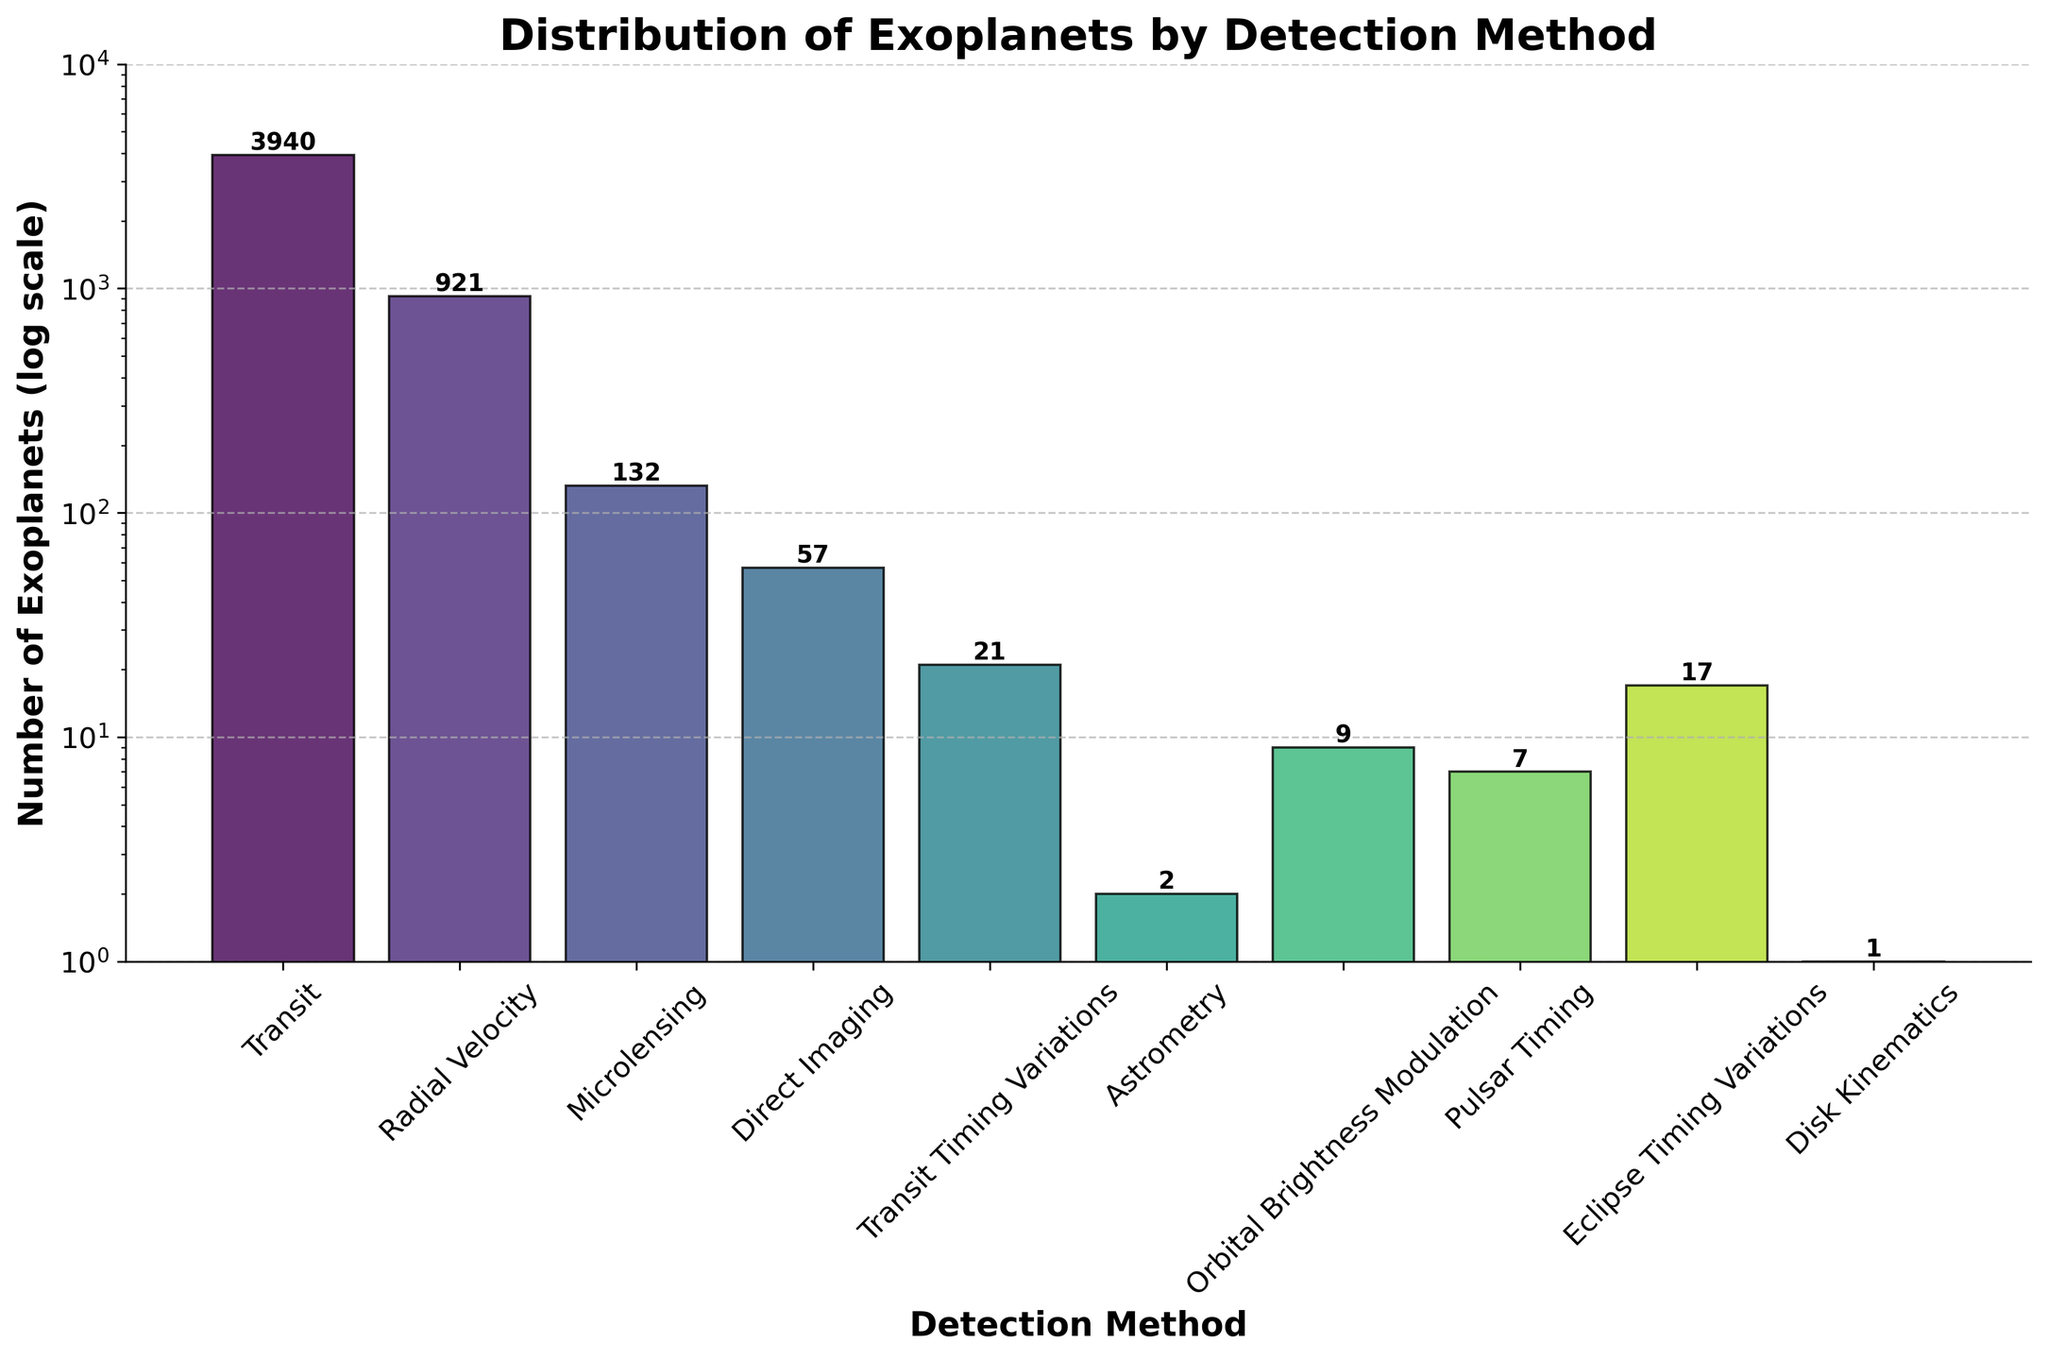Which detection method has discovered the most exoplanets? The bar representing the "Transit" method is the tallest in the chart. This indicates that the Transit method has discovered the highest number of exoplanets.
Answer: Transit What is the detection method with the second-highest number of discovered exoplanets? The second tallest bar in the chart corresponds to the "Radial Velocity" method. This bar is shorter than the "Transit" method but taller than the rest.
Answer: Radial Velocity How many exoplanets have been discovered using the Direct Imaging method? The height of the bar for "Direct Imaging" has the value written directly above it, indicating the number of discovered exoplanets.
Answer: 57 What is the sum of exoplanets discovered through Microlensing and Direct Imaging methods? The number of exoplanets discovered by Microlensing is 132, and by Direct Imaging is 57. Adding these values gives 132 + 57 = 189.
Answer: 189 Which detection methods have discovered fewer than 10 exoplanets? The bars for "Astrometry", "Orbital Brightness Modulation", "Pulsar Timing", and "Disk Kinematics" all indicate fewer than 10 exoplanets discovered, based on their heights and the numbers directly written above them.
Answer: Astrometry, Orbital Brightness Modulation, Pulsar Timing, Disk Kinematics What's the difference in the number of exoplanets discovered between the Transit and Eclipse Timing Variations methods? The Transit method has discovered 3940 exoplanets, whereas the Eclipse Timing Variations method has discovered 17. The difference is 3940 - 17 = 3923.
Answer: 3923 Rank the detection methods in terms of the number of discovered exoplanets, from highest to lowest. The chart shows the number of discovered exoplanets for each method. Ranked from highest to lowest: Transit (3940), Radial Velocity (921), Microlensing (132), Direct Imaging (57), Transit Timing Variations (21), Eclipse Timing Variations (17), Orbital Brightness Modulation (9), Pulsar Timing (7), Astrometry (2), Disk Kinematics (1).
Answer: Transit, Radial Velocity, Microlensing, Direct Imaging, Transit Timing Variations, Eclipse Timing Variations, Orbital Brightness Modulation, Pulsar Timing, Astrometry, Disk Kinematics 